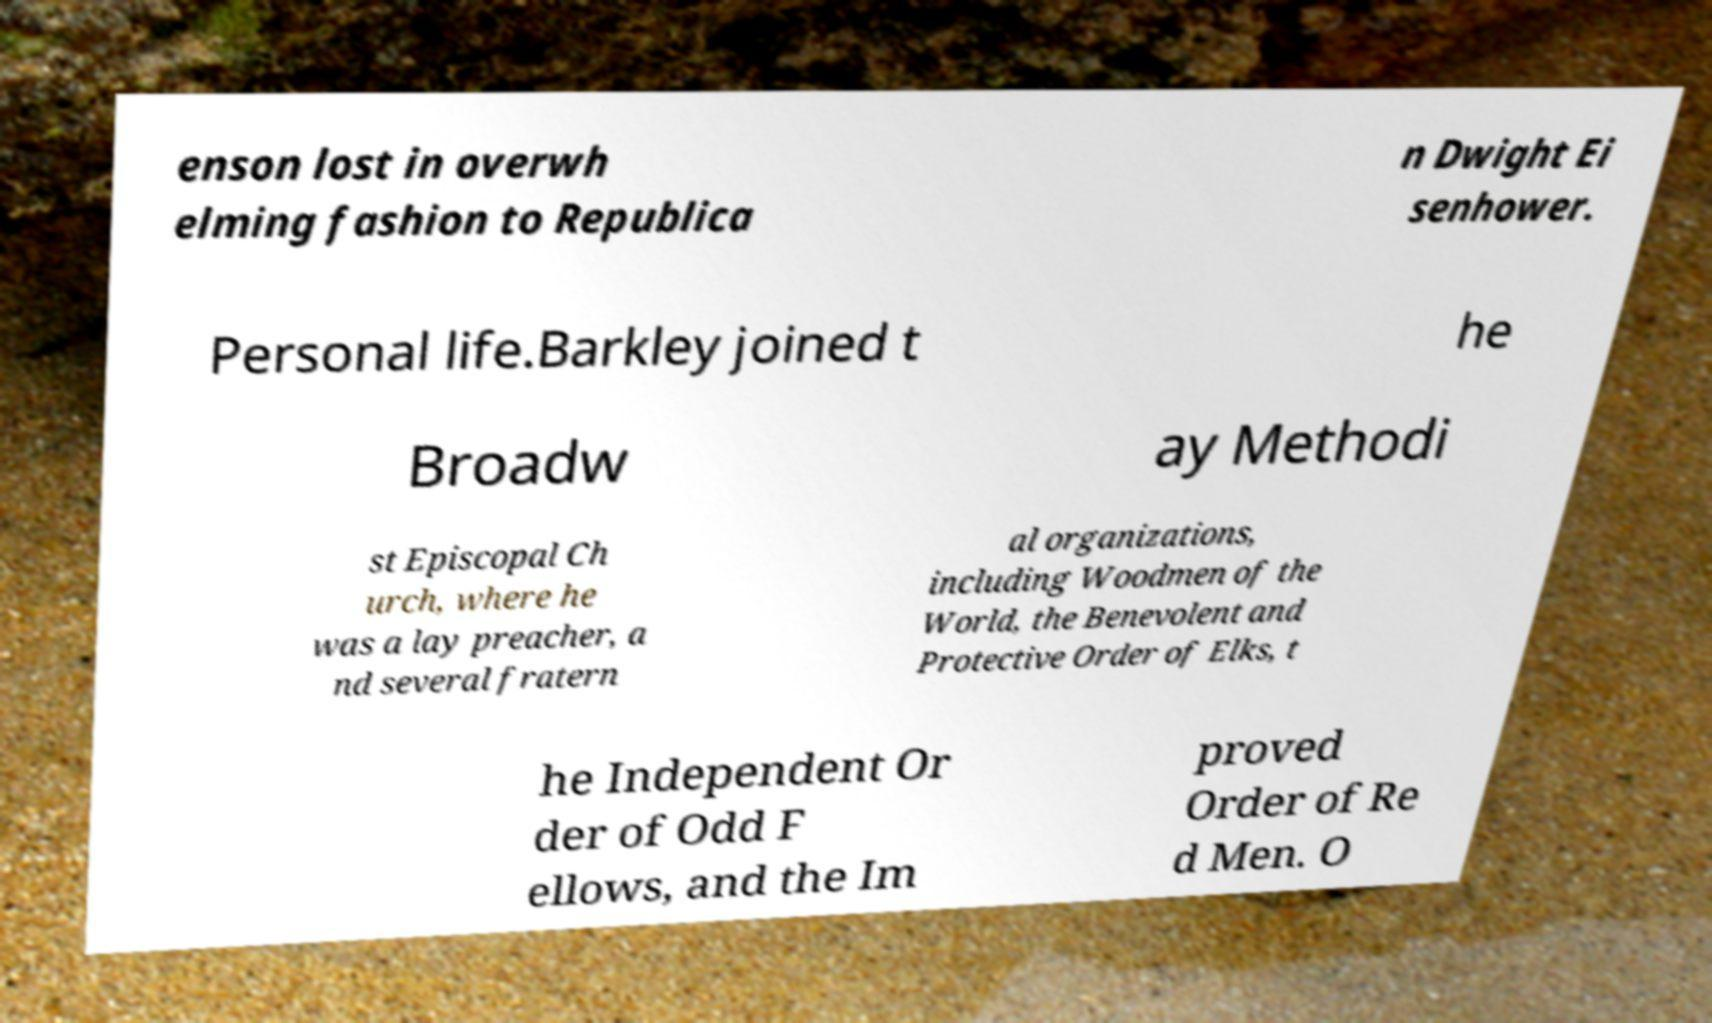Please read and relay the text visible in this image. What does it say? enson lost in overwh elming fashion to Republica n Dwight Ei senhower. Personal life.Barkley joined t he Broadw ay Methodi st Episcopal Ch urch, where he was a lay preacher, a nd several fratern al organizations, including Woodmen of the World, the Benevolent and Protective Order of Elks, t he Independent Or der of Odd F ellows, and the Im proved Order of Re d Men. O 